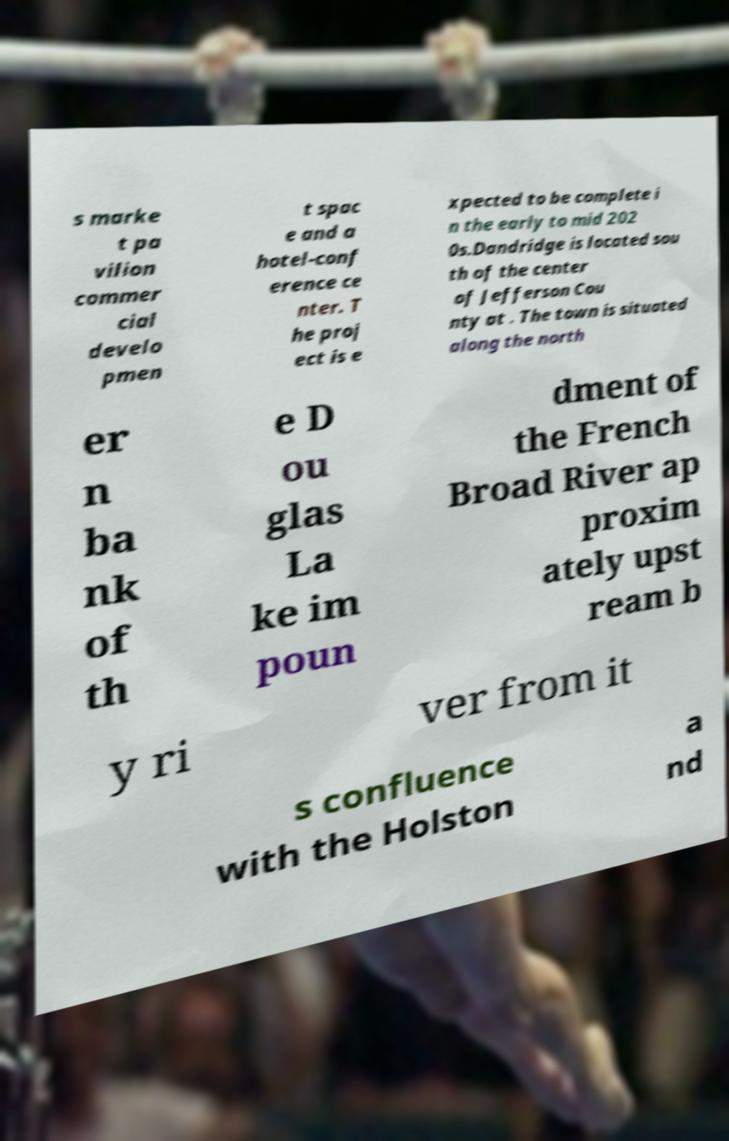Can you accurately transcribe the text from the provided image for me? s marke t pa vilion commer cial develo pmen t spac e and a hotel-conf erence ce nter. T he proj ect is e xpected to be complete i n the early to mid 202 0s.Dandridge is located sou th of the center of Jefferson Cou nty at . The town is situated along the north er n ba nk of th e D ou glas La ke im poun dment of the French Broad River ap proxim ately upst ream b y ri ver from it s confluence with the Holston a nd 